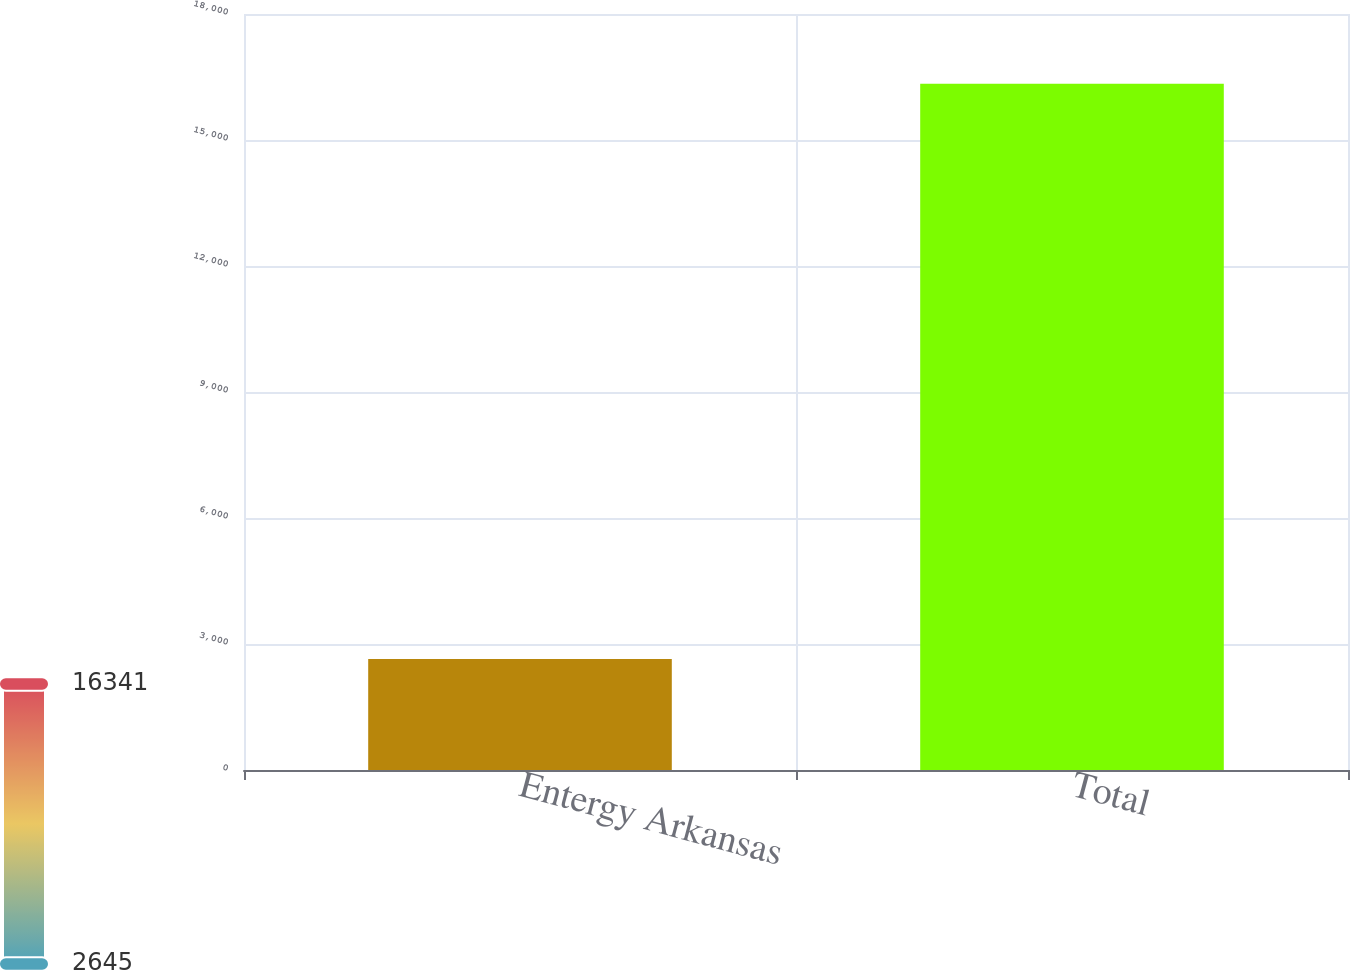<chart> <loc_0><loc_0><loc_500><loc_500><bar_chart><fcel>Entergy Arkansas<fcel>Total<nl><fcel>2645<fcel>16341<nl></chart> 